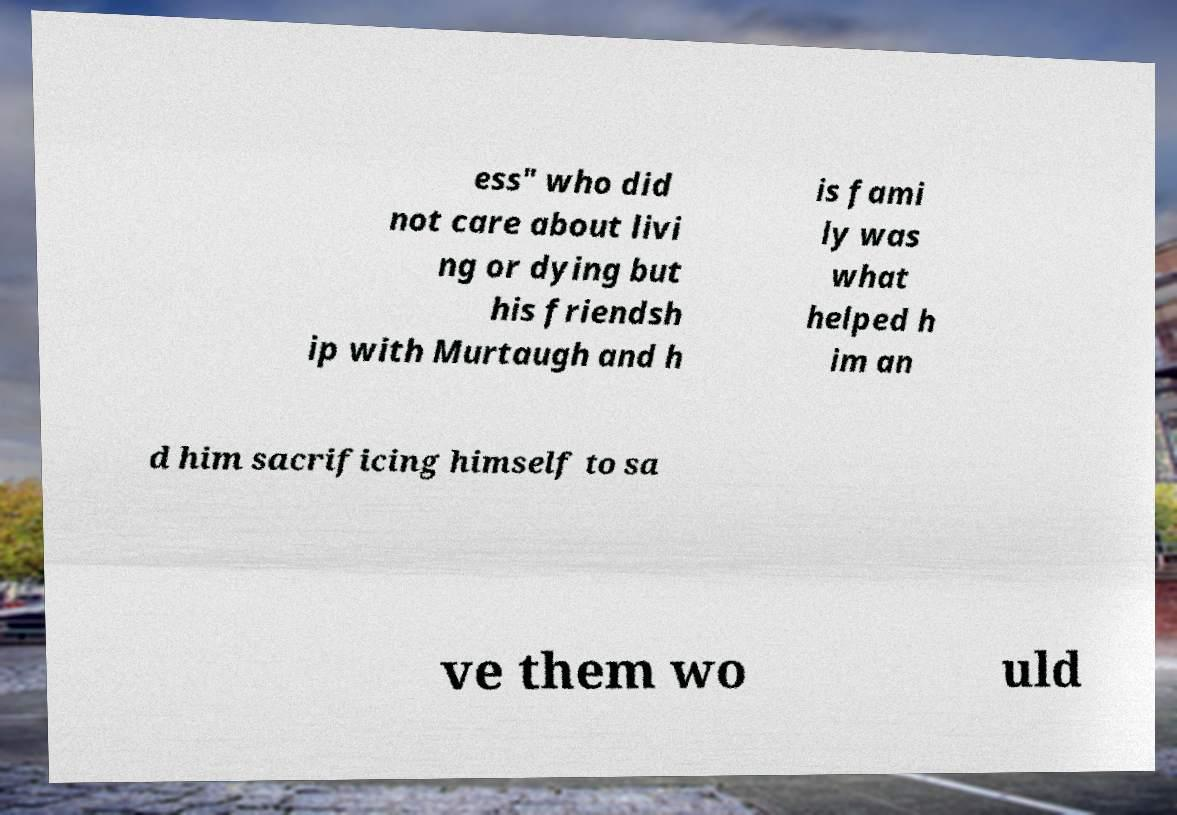There's text embedded in this image that I need extracted. Can you transcribe it verbatim? ess" who did not care about livi ng or dying but his friendsh ip with Murtaugh and h is fami ly was what helped h im an d him sacrificing himself to sa ve them wo uld 